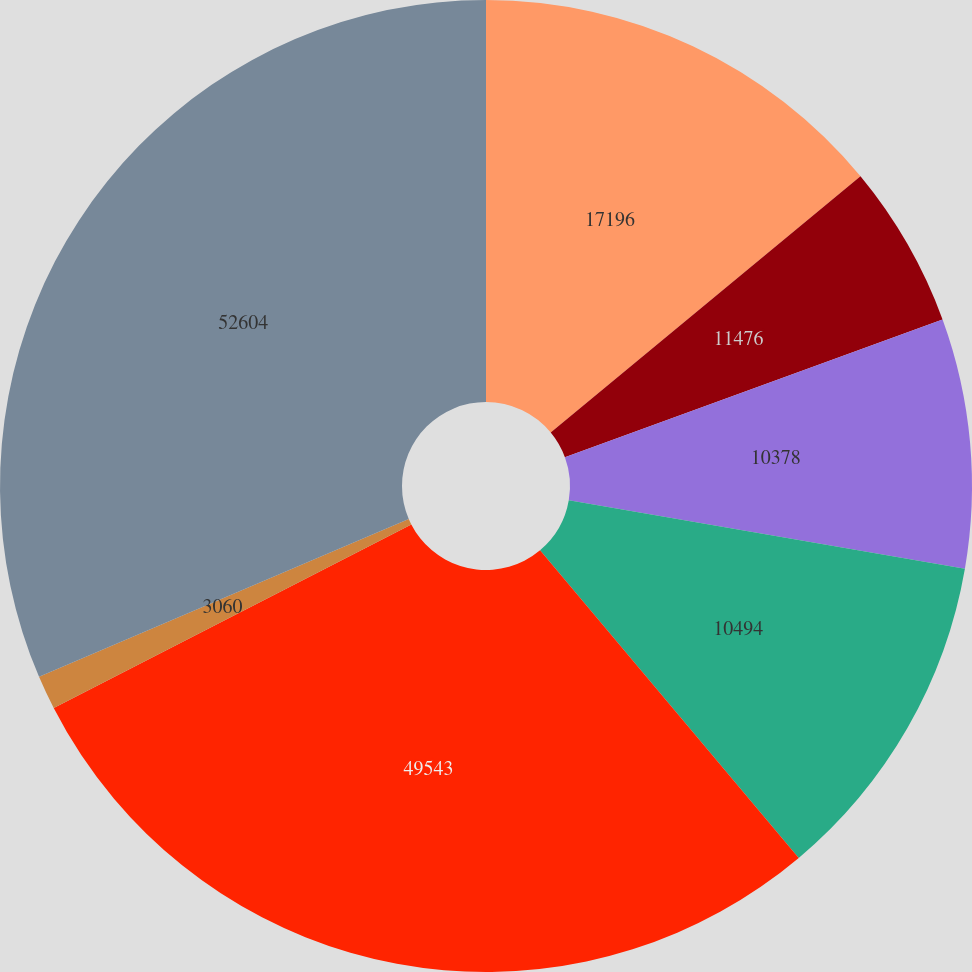Convert chart. <chart><loc_0><loc_0><loc_500><loc_500><pie_chart><fcel>17196<fcel>11476<fcel>10378<fcel>10494<fcel>49543<fcel>3060<fcel>52604<nl><fcel>14.0%<fcel>5.43%<fcel>8.29%<fcel>11.15%<fcel>28.57%<fcel>1.13%<fcel>31.42%<nl></chart> 